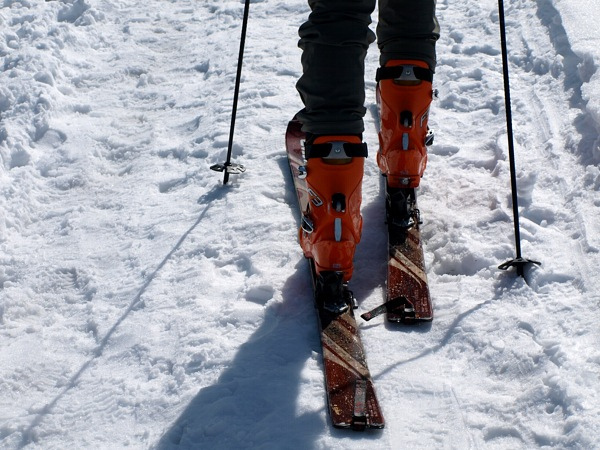<image>Are the skis made out of plastic? I don't know. The skis could be made out of different materials, not just plastic. Are the skis made out of plastic? I don't know if the skis are made out of plastic. It is unclear from the image. 